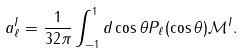<formula> <loc_0><loc_0><loc_500><loc_500>a _ { \ell } ^ { I } = \frac { 1 } { 3 2 \pi } \int _ { - 1 } ^ { 1 } d \cos \theta P _ { \ell } ( \cos \theta ) \mathcal { M } ^ { I } .</formula> 